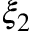<formula> <loc_0><loc_0><loc_500><loc_500>\xi _ { 2 }</formula> 